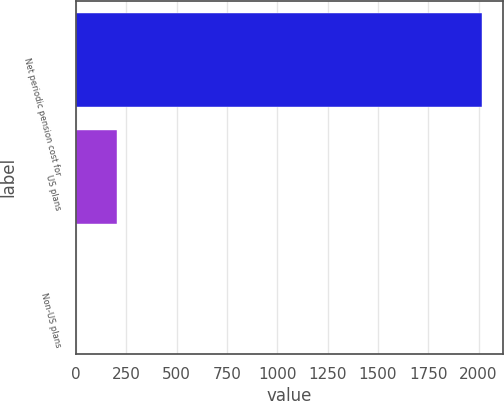<chart> <loc_0><loc_0><loc_500><loc_500><bar_chart><fcel>Net periodic pension cost for<fcel>US plans<fcel>Non-US plans<nl><fcel>2018<fcel>204.05<fcel>2.5<nl></chart> 